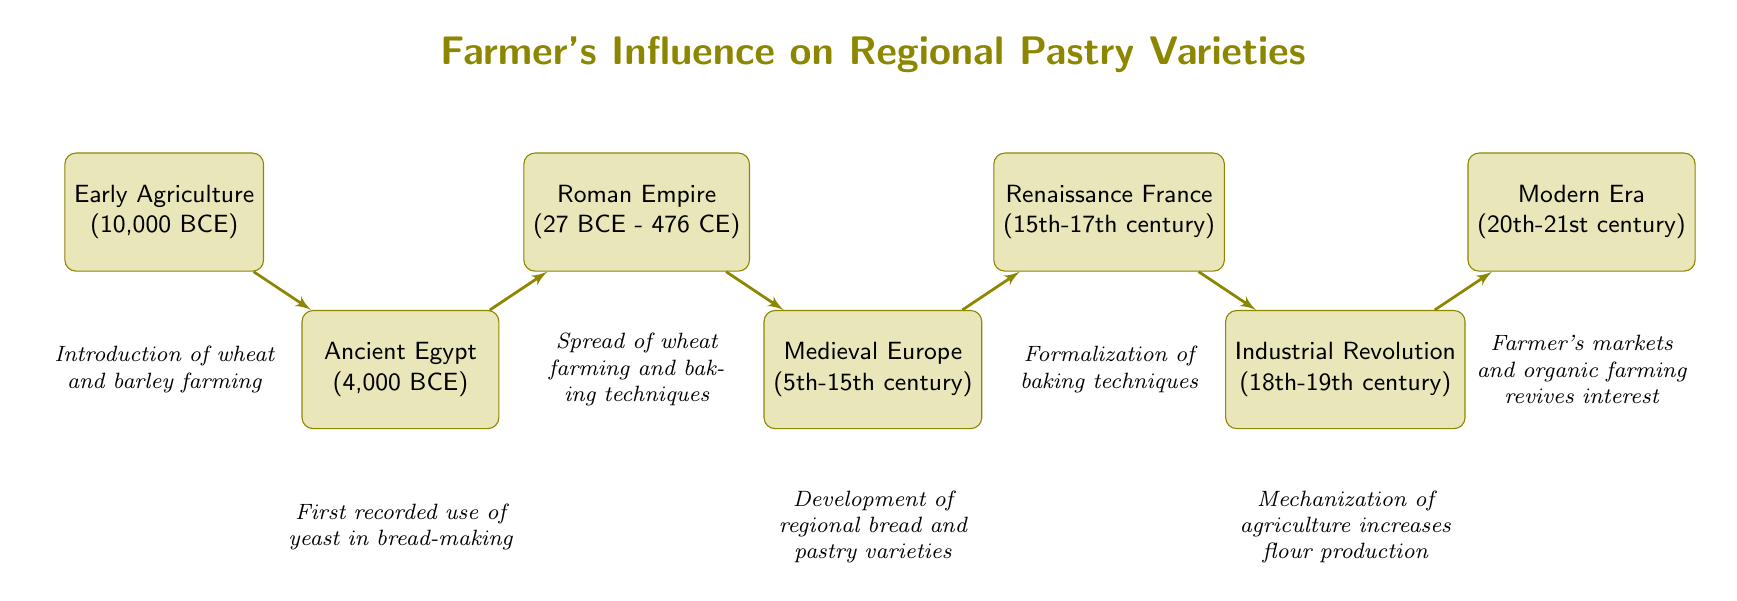What is the first node in the flow chart? The flow chart begins with "Early Agriculture," which is the earliest point in the sequence.
Answer: Early Agriculture In what year did Ancient Egypt first record the use of yeast? According to the diagram, Ancient Egypt is associated with the year 4,000 BCE for the first recorded use of yeast in bread-making.
Answer: 4,000 BCE How many nodes are there in total? Counting each point in the flow chart, there are seven nodes representing different historical stages.
Answer: 7 What is the relationship between the Medieval Europe node and the Renaissance France node? The diagram indicates a direct connection from Medieval Europe to Renaissance France, suggesting that developments in Medieval Europe led directly to the emergence of baking techniques in Renaissance France.
Answer: Direct connection What major development occurred during the Industrial Revolution? The flow chart highlights the mechanization of agriculture as the key development during the Industrial Revolution in the 18th-19th century.
Answer: Mechanization of agriculture increases flour production Which node indicates the revival of interest in traditional ingredients? The last node in the flow chart, "Modern Era," signifies the revival of interest in traditional grains and ingredients through farmer's markets and organic farming in the 20th-21st century.
Answer: Modern Era What period does the Roman Empire span in the chart? Referring to the diagram, the Roman Empire is noted to span from 27 BCE to 476 CE, marking the spread of wheat farming and baking techniques across Europe.
Answer: 27 BCE - 476 CE Which node connects the Ancient Egypt and Roman Empire nodes? The connection leading from Ancient Egypt to Roman Empire indicates a historical progression that showcases the evolution of baking practices influenced by the earlier Egyptian use of yeast.
Answer: Roman Empire What was a significant outcome of Medieval Europe concerning pastries? The diagram specifically mentions that Medieval Europe was the stage where regional bread and pastry varieties were developed using local grains and fruits, illustrating the significant outcomes of this era.
Answer: Development of regional bread and pastry varieties 